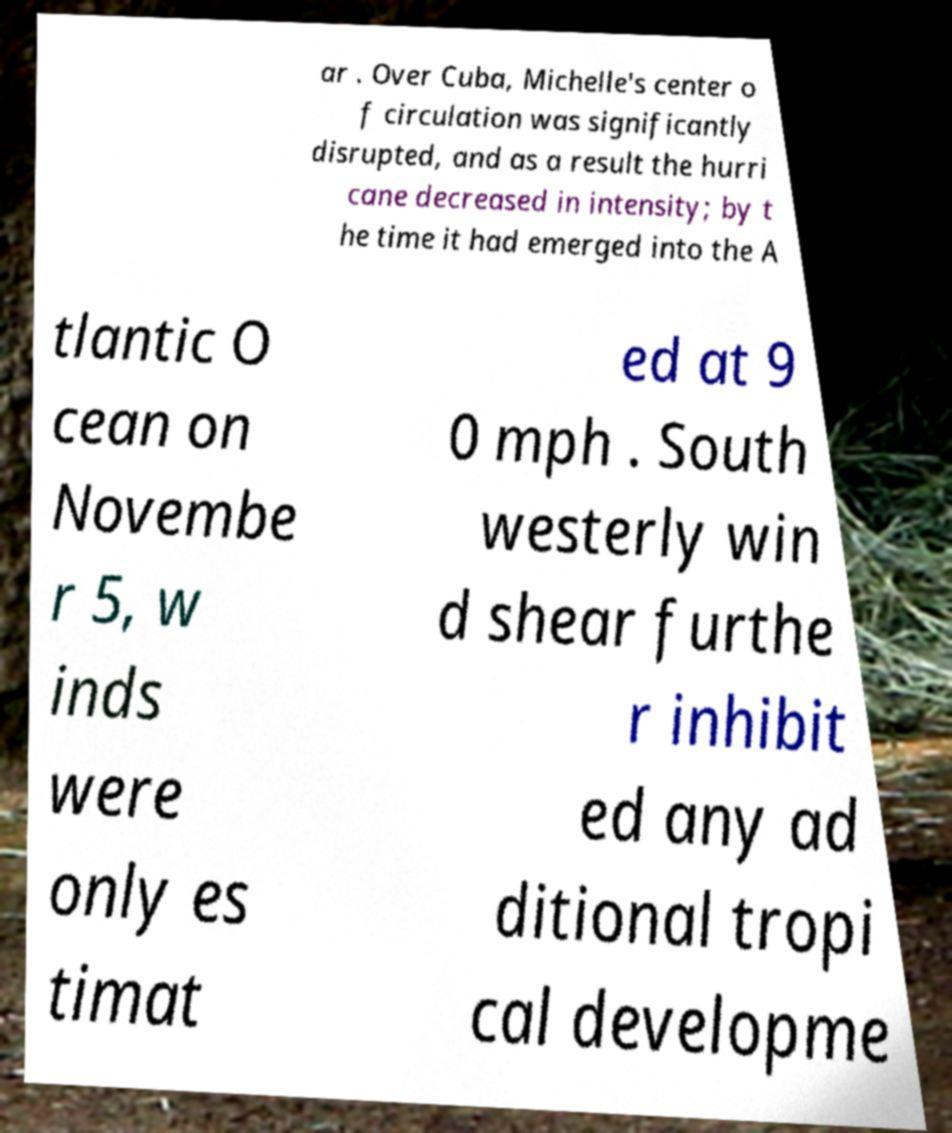I need the written content from this picture converted into text. Can you do that? ar . Over Cuba, Michelle's center o f circulation was significantly disrupted, and as a result the hurri cane decreased in intensity; by t he time it had emerged into the A tlantic O cean on Novembe r 5, w inds were only es timat ed at 9 0 mph . South westerly win d shear furthe r inhibit ed any ad ditional tropi cal developme 